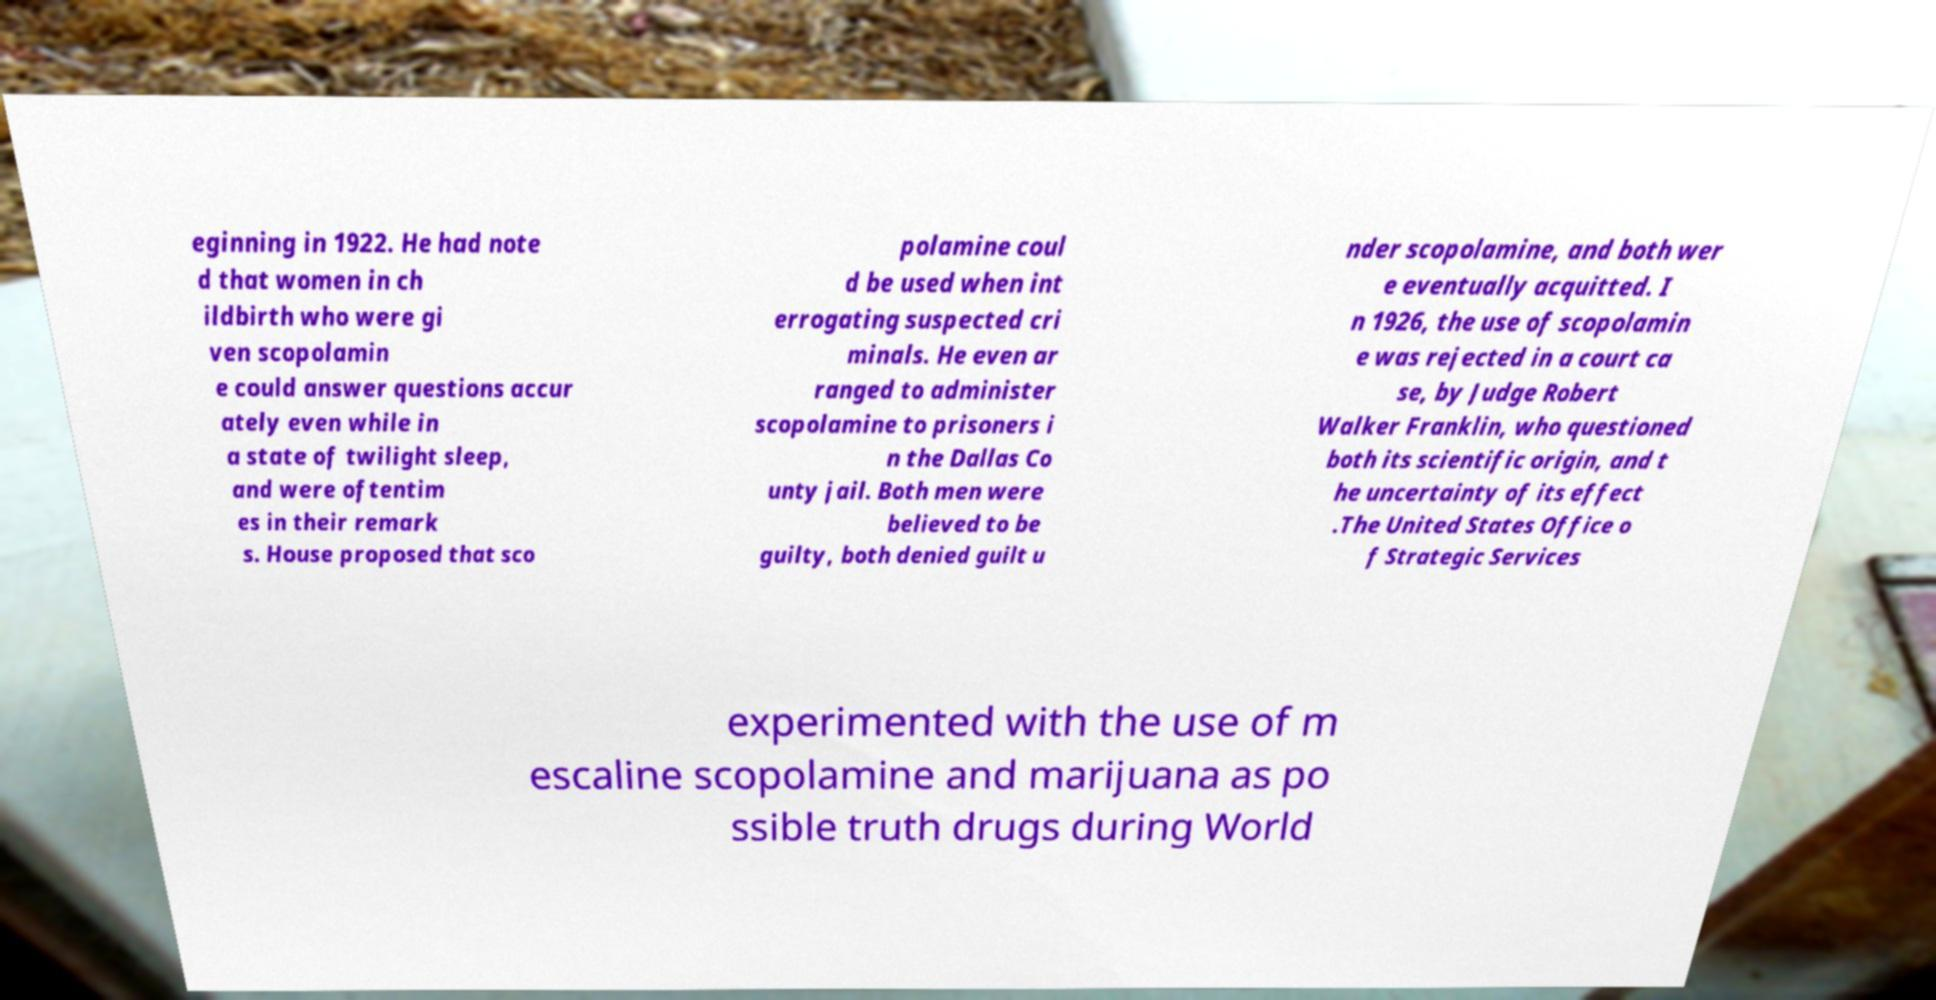Could you extract and type out the text from this image? eginning in 1922. He had note d that women in ch ildbirth who were gi ven scopolamin e could answer questions accur ately even while in a state of twilight sleep, and were oftentim es in their remark s. House proposed that sco polamine coul d be used when int errogating suspected cri minals. He even ar ranged to administer scopolamine to prisoners i n the Dallas Co unty jail. Both men were believed to be guilty, both denied guilt u nder scopolamine, and both wer e eventually acquitted. I n 1926, the use of scopolamin e was rejected in a court ca se, by Judge Robert Walker Franklin, who questioned both its scientific origin, and t he uncertainty of its effect .The United States Office o f Strategic Services experimented with the use of m escaline scopolamine and marijuana as po ssible truth drugs during World 